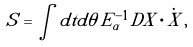<formula> <loc_0><loc_0><loc_500><loc_500>S = \int d t d \theta \, E _ { \alpha } ^ { - 1 } D X \cdot \dot { X } \, ,</formula> 